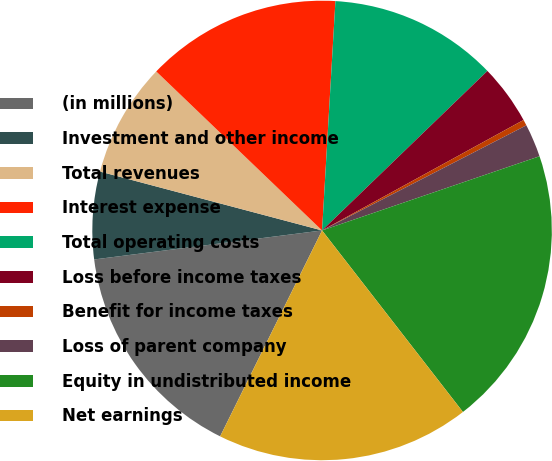Convert chart. <chart><loc_0><loc_0><loc_500><loc_500><pie_chart><fcel>(in millions)<fcel>Investment and other income<fcel>Total revenues<fcel>Interest expense<fcel>Total operating costs<fcel>Loss before income taxes<fcel>Benefit for income taxes<fcel>Loss of parent company<fcel>Equity in undistributed income<fcel>Net earnings<nl><fcel>15.67%<fcel>6.14%<fcel>8.04%<fcel>13.76%<fcel>11.86%<fcel>4.23%<fcel>0.42%<fcel>2.33%<fcel>19.73%<fcel>17.82%<nl></chart> 